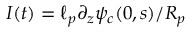<formula> <loc_0><loc_0><loc_500><loc_500>I ( t ) = \ell _ { p } \partial _ { z } \psi _ { c } ( 0 , s ) / R _ { p }</formula> 